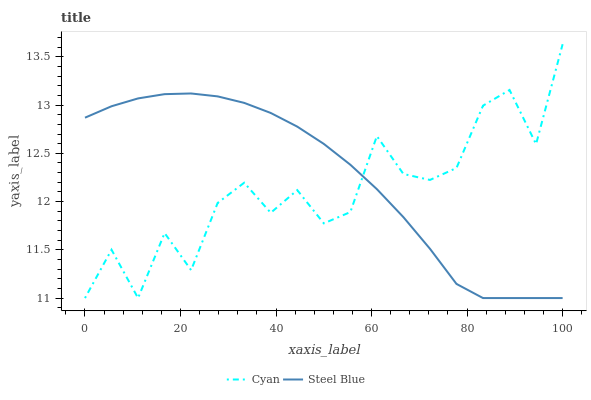Does Cyan have the minimum area under the curve?
Answer yes or no. Yes. Does Steel Blue have the maximum area under the curve?
Answer yes or no. Yes. Does Steel Blue have the minimum area under the curve?
Answer yes or no. No. Is Steel Blue the smoothest?
Answer yes or no. Yes. Is Cyan the roughest?
Answer yes or no. Yes. Is Steel Blue the roughest?
Answer yes or no. No. Does Cyan have the lowest value?
Answer yes or no. Yes. Does Cyan have the highest value?
Answer yes or no. Yes. Does Steel Blue have the highest value?
Answer yes or no. No. Does Steel Blue intersect Cyan?
Answer yes or no. Yes. Is Steel Blue less than Cyan?
Answer yes or no. No. Is Steel Blue greater than Cyan?
Answer yes or no. No. 